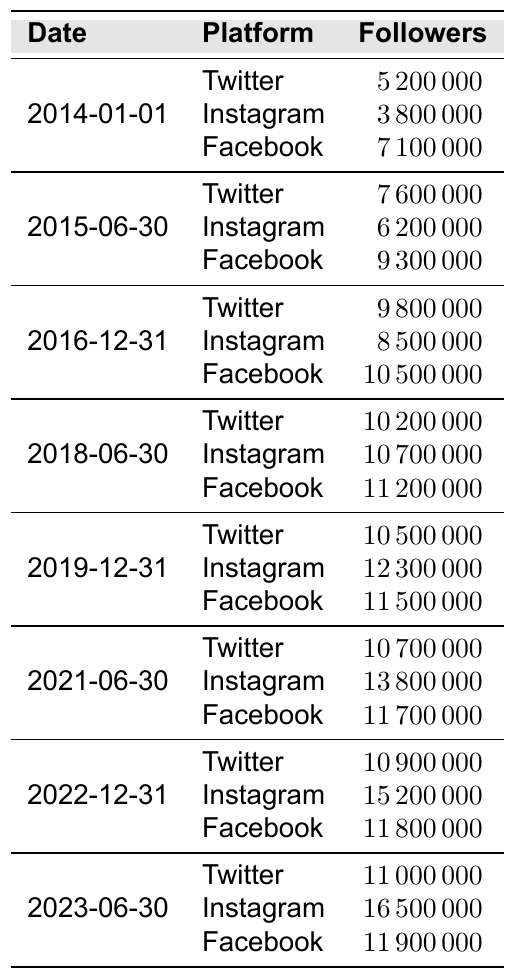What were Austin Mahone's Twitter followers on June 30, 2019? The table indicates that on June 30, 2019, Austin Mahone had 10,500,000 Twitter followers.
Answer: 10,500,000 What is the increase in Austin Mahone's Instagram followers from December 31, 2016 to December 31, 2022? The Instagram followers on December 31, 2016 were 8,500,000, and on December 31, 2022, they were 15,200,000. The increase is 15,200,000 - 8,500,000 = 6,700,000.
Answer: 6,700,000 Did Austin Mahone have more Facebook followers than Twitter followers on June 30, 2021? On June 30, 2021, Austin Mahone had 11,700,000 Facebook followers and 10,700,000 Twitter followers. Since 11,700,000 > 10,700,000, the answer is yes.
Answer: Yes Which platform had the highest percentage increase in followers from January 1, 2014 to June 30, 2023? To find this, we calculate the percentage increase for each platform. For Twitter: (11,000,000 - 5,200,000) / 5,200,000 * 100 = 111.54%. For Instagram: (16,500,000 - 3,800,000) / 3,800,000 * 100 = 335.53%. For Facebook: (11,900,000 - 7,100,000) / 7,100,000 * 100 = 67.61%. The highest increase is for Instagram with 335.53%.
Answer: Instagram What were the average followers across all platforms on December 31, 2022? The totals for December 31, 2022 are: Twitter 10,900,000, Instagram 15,200,000, and Facebook 11,800,000. The average is (10,900,000 + 15,200,000 + 11,800,000) / 3 = 12,300,000.
Answer: 12,300,000 How many followers did Austin Mahone have on Facebook by the end of 2018? According to the table, Austin Mahone had 11,200,000 Facebook followers at the end of June 2018.
Answer: 11,200,000 Which platform had the lowest number of followers across the entire timeline? By evaluating the data, Instagram had the least amount of followers on January 1, 2014, with 3,800,000.
Answer: Instagram Was there a time when Austin Mahone's Twitter followers exceeded his Facebook followers? By examining the data, Twitter's highest follower count is 11,000,000 (on June 30, 2023) which is still less than Facebook's 11,900,000 at the same time. Therefore, the answer is no.
Answer: No 